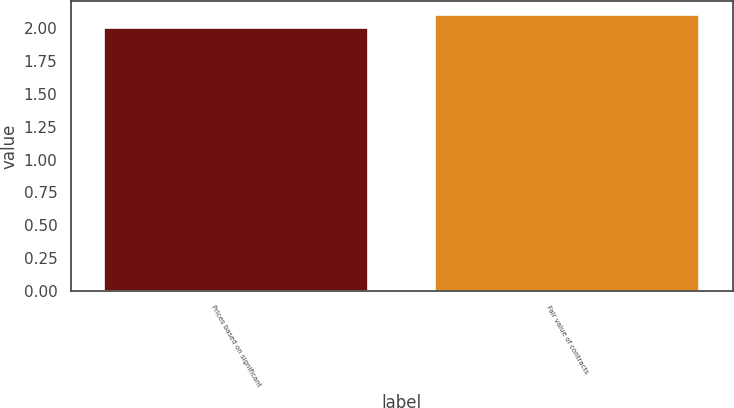Convert chart to OTSL. <chart><loc_0><loc_0><loc_500><loc_500><bar_chart><fcel>Prices based on significant<fcel>Fair value of contracts<nl><fcel>2<fcel>2.1<nl></chart> 